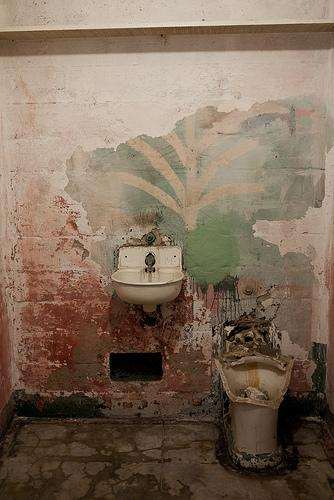Question: what type of room is in the picture?
Choices:
A. Shower room.
B. Kitchen.
C. A bathroom.
D. Outhouse.
Answer with the letter. Answer: C Question: what structure is on the left side of the picture?
Choices:
A. A sink.
B. Dishwasher.
C. Cabinetry.
D. Wall.
Answer with the letter. Answer: A Question: when would someone want to use the structure on the left side of the picture?
Choices:
A. To get some gum.
B. To play a song.
C. To see something far away.
D. To wash their hands.
Answer with the letter. Answer: D Question: where is there green paint?
Choices:
A. On the roof.
B. On the back wall.
C. On the sidewalk.
D. On the statue.
Answer with the letter. Answer: B Question: how could someone describe the structures in the picture?
Choices:
A. In perfect condition.
B. Falling apart.
C. Fairly well maintained.
D. Under construction.
Answer with the letter. Answer: B Question: what is on the right side of the picture?
Choices:
A. A sink.
B. A stool.
C. A towel rack.
D. A toilet.
Answer with the letter. Answer: D Question: who would have painted the walls of the room in the picture?
Choices:
A. A child.
B. A landscape painter.
C. A graffiti artist.
D. A homeowner.
Answer with the letter. Answer: C Question: why wouldn't someone want to utilize this room?
Choices:
A. It's poorly decorated.
B. It's too fancy.
C. It's full of bees.
D. It's falling apart.
Answer with the letter. Answer: D 